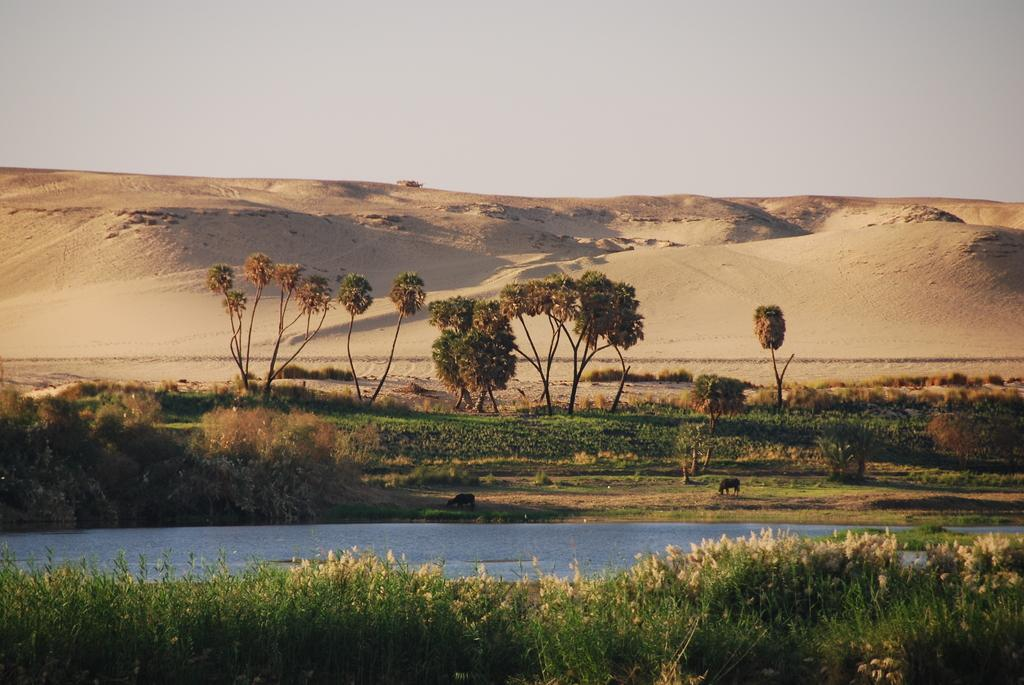What type of water feature is present in the image? There is a canal in the image. What can be seen at the bottom of the image? There are plants at the bottom of the image. What geographical features are in the middle of the image? There are hills and trees in the middle of the image. What is visible at the top of the image? The sky is visible at the top of the image. What type of watch is the tree wearing in the image? There are no watches present in the image, and trees do not wear watches. 